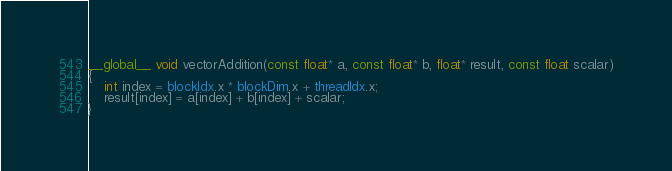<code> <loc_0><loc_0><loc_500><loc_500><_Cuda_>__global__ void vectorAddition(const float* a, const float* b, float* result, const float scalar)
{
    int index = blockIdx.x * blockDim.x + threadIdx.x;
    result[index] = a[index] + b[index] + scalar;
}
</code> 